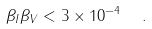Convert formula to latex. <formula><loc_0><loc_0><loc_500><loc_500>\beta _ { I } \beta _ { V } < 3 \times 1 0 ^ { - 4 } \ \ .</formula> 